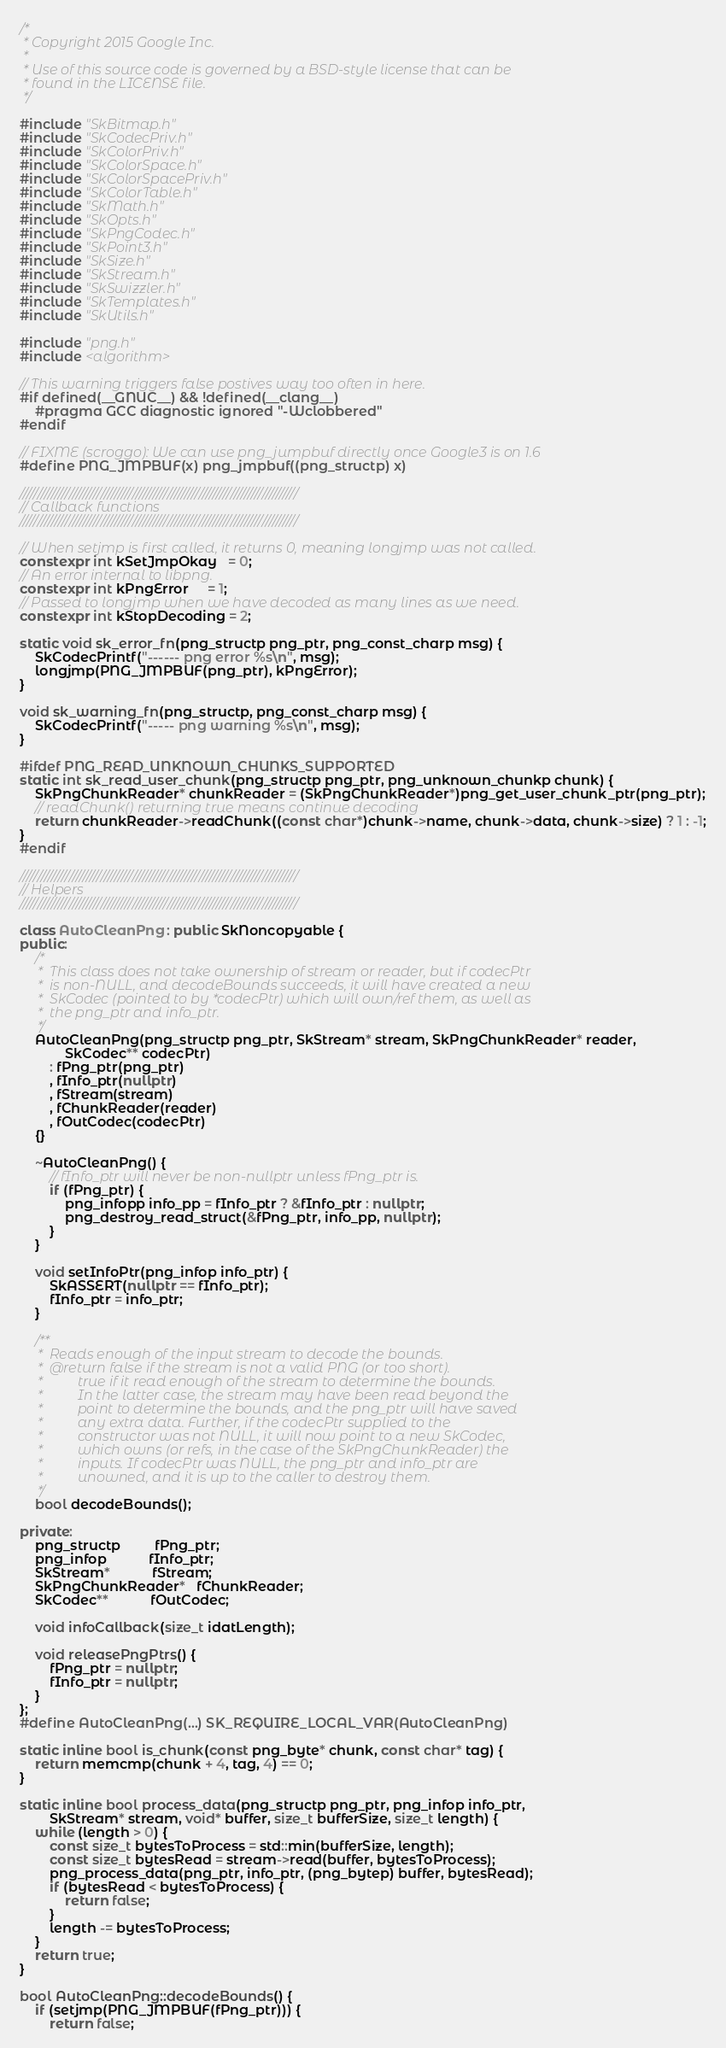Convert code to text. <code><loc_0><loc_0><loc_500><loc_500><_C++_>/*
 * Copyright 2015 Google Inc.
 *
 * Use of this source code is governed by a BSD-style license that can be
 * found in the LICENSE file.
 */

#include "SkBitmap.h"
#include "SkCodecPriv.h"
#include "SkColorPriv.h"
#include "SkColorSpace.h"
#include "SkColorSpacePriv.h"
#include "SkColorTable.h"
#include "SkMath.h"
#include "SkOpts.h"
#include "SkPngCodec.h"
#include "SkPoint3.h"
#include "SkSize.h"
#include "SkStream.h"
#include "SkSwizzler.h"
#include "SkTemplates.h"
#include "SkUtils.h"

#include "png.h"
#include <algorithm>

// This warning triggers false postives way too often in here.
#if defined(__GNUC__) && !defined(__clang__)
    #pragma GCC diagnostic ignored "-Wclobbered"
#endif

// FIXME (scroggo): We can use png_jumpbuf directly once Google3 is on 1.6
#define PNG_JMPBUF(x) png_jmpbuf((png_structp) x)

///////////////////////////////////////////////////////////////////////////////
// Callback functions
///////////////////////////////////////////////////////////////////////////////

// When setjmp is first called, it returns 0, meaning longjmp was not called.
constexpr int kSetJmpOkay   = 0;
// An error internal to libpng.
constexpr int kPngError     = 1;
// Passed to longjmp when we have decoded as many lines as we need.
constexpr int kStopDecoding = 2;

static void sk_error_fn(png_structp png_ptr, png_const_charp msg) {
    SkCodecPrintf("------ png error %s\n", msg);
    longjmp(PNG_JMPBUF(png_ptr), kPngError);
}

void sk_warning_fn(png_structp, png_const_charp msg) {
    SkCodecPrintf("----- png warning %s\n", msg);
}

#ifdef PNG_READ_UNKNOWN_CHUNKS_SUPPORTED
static int sk_read_user_chunk(png_structp png_ptr, png_unknown_chunkp chunk) {
    SkPngChunkReader* chunkReader = (SkPngChunkReader*)png_get_user_chunk_ptr(png_ptr);
    // readChunk() returning true means continue decoding
    return chunkReader->readChunk((const char*)chunk->name, chunk->data, chunk->size) ? 1 : -1;
}
#endif

///////////////////////////////////////////////////////////////////////////////
// Helpers
///////////////////////////////////////////////////////////////////////////////

class AutoCleanPng : public SkNoncopyable {
public:
    /*
     *  This class does not take ownership of stream or reader, but if codecPtr
     *  is non-NULL, and decodeBounds succeeds, it will have created a new
     *  SkCodec (pointed to by *codecPtr) which will own/ref them, as well as
     *  the png_ptr and info_ptr.
     */
    AutoCleanPng(png_structp png_ptr, SkStream* stream, SkPngChunkReader* reader,
            SkCodec** codecPtr)
        : fPng_ptr(png_ptr)
        , fInfo_ptr(nullptr)
        , fStream(stream)
        , fChunkReader(reader)
        , fOutCodec(codecPtr)
    {}

    ~AutoCleanPng() {
        // fInfo_ptr will never be non-nullptr unless fPng_ptr is.
        if (fPng_ptr) {
            png_infopp info_pp = fInfo_ptr ? &fInfo_ptr : nullptr;
            png_destroy_read_struct(&fPng_ptr, info_pp, nullptr);
        }
    }

    void setInfoPtr(png_infop info_ptr) {
        SkASSERT(nullptr == fInfo_ptr);
        fInfo_ptr = info_ptr;
    }

    /**
     *  Reads enough of the input stream to decode the bounds.
     *  @return false if the stream is not a valid PNG (or too short).
     *          true if it read enough of the stream to determine the bounds.
     *          In the latter case, the stream may have been read beyond the
     *          point to determine the bounds, and the png_ptr will have saved
     *          any extra data. Further, if the codecPtr supplied to the
     *          constructor was not NULL, it will now point to a new SkCodec,
     *          which owns (or refs, in the case of the SkPngChunkReader) the
     *          inputs. If codecPtr was NULL, the png_ptr and info_ptr are
     *          unowned, and it is up to the caller to destroy them.
     */
    bool decodeBounds();

private:
    png_structp         fPng_ptr;
    png_infop           fInfo_ptr;
    SkStream*           fStream;
    SkPngChunkReader*   fChunkReader;
    SkCodec**           fOutCodec;

    void infoCallback(size_t idatLength);

    void releasePngPtrs() {
        fPng_ptr = nullptr;
        fInfo_ptr = nullptr;
    }
};
#define AutoCleanPng(...) SK_REQUIRE_LOCAL_VAR(AutoCleanPng)

static inline bool is_chunk(const png_byte* chunk, const char* tag) {
    return memcmp(chunk + 4, tag, 4) == 0;
}

static inline bool process_data(png_structp png_ptr, png_infop info_ptr,
        SkStream* stream, void* buffer, size_t bufferSize, size_t length) {
    while (length > 0) {
        const size_t bytesToProcess = std::min(bufferSize, length);
        const size_t bytesRead = stream->read(buffer, bytesToProcess);
        png_process_data(png_ptr, info_ptr, (png_bytep) buffer, bytesRead);
        if (bytesRead < bytesToProcess) {
            return false;
        }
        length -= bytesToProcess;
    }
    return true;
}

bool AutoCleanPng::decodeBounds() {
    if (setjmp(PNG_JMPBUF(fPng_ptr))) {
        return false;</code> 